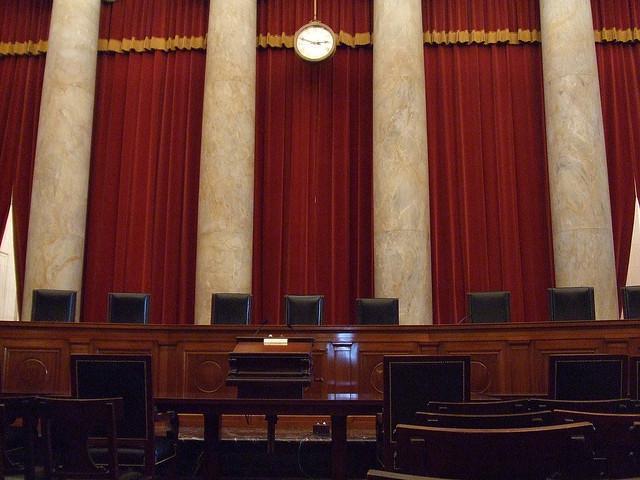How many chairs can you see?
Give a very brief answer. 6. How many zebras are there?
Give a very brief answer. 0. 